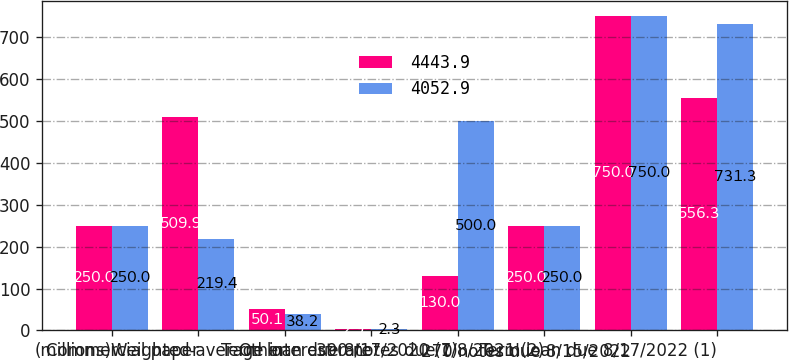Convert chart to OTSL. <chart><loc_0><loc_0><loc_500><loc_500><stacked_bar_chart><ecel><fcel>(millions)<fcel>Commercial paper<fcel>Other<fcel>Weighted-average interest rate<fcel>Term loan due 8/17/2020 (1)<fcel>390 notes due 7/8/2021 (2)<fcel>270 notes due 8/15/2022<fcel>Term loan due 8/17/2022 (1)<nl><fcel>4443.9<fcel>250<fcel>509.9<fcel>50.1<fcel>2.9<fcel>130<fcel>250<fcel>750<fcel>556.3<nl><fcel>4052.9<fcel>250<fcel>219.4<fcel>38.2<fcel>2.3<fcel>500<fcel>250<fcel>750<fcel>731.3<nl></chart> 